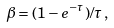<formula> <loc_0><loc_0><loc_500><loc_500>\beta = ( 1 - e ^ { - \tau } ) / \tau \, ,</formula> 